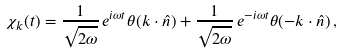<formula> <loc_0><loc_0><loc_500><loc_500>\chi _ { k } ( t ) = \frac { 1 } { \sqrt { 2 \omega } } \, e ^ { i \omega t } \theta ( k \cdot \hat { n } ) + \frac { 1 } { \sqrt { 2 \omega } } \, e ^ { - i \omega t } \theta ( - k \cdot \hat { n } ) \, ,</formula> 